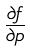<formula> <loc_0><loc_0><loc_500><loc_500>\frac { \partial f } { \partial p }</formula> 